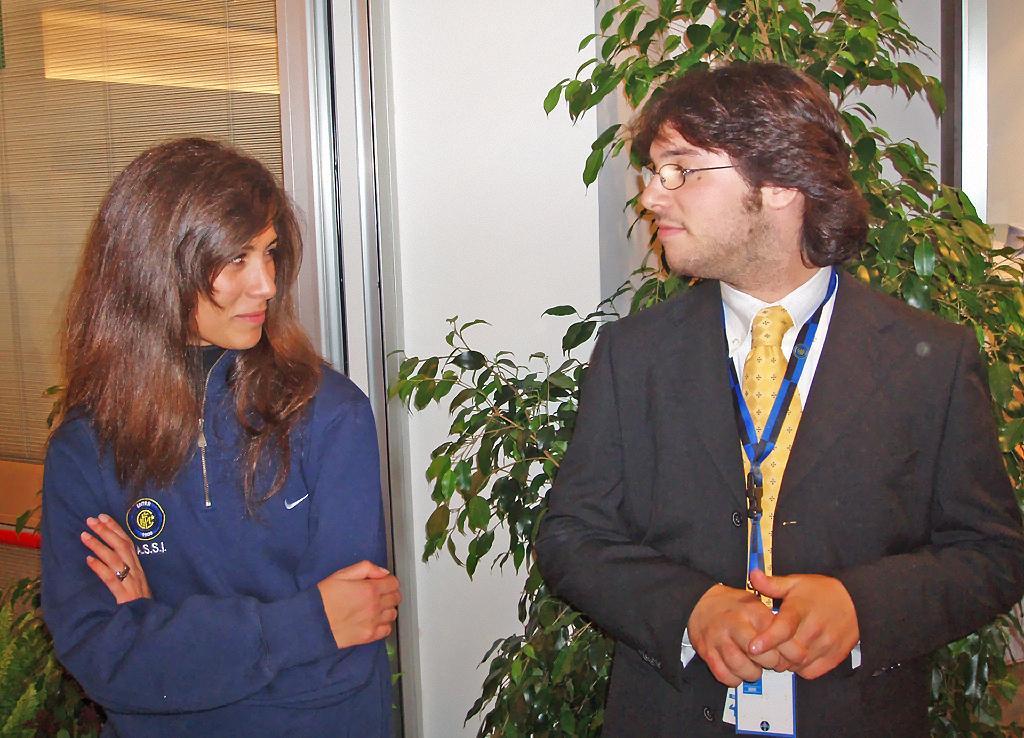Could you give a brief overview of what you see in this image? In this image there is a man and a woman standing, in the background there is a plant and a wall to that wall there is a door. 